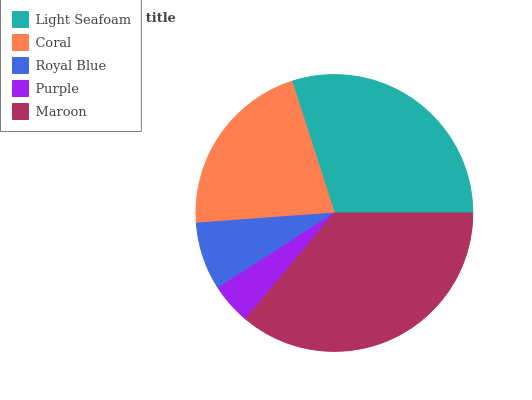Is Purple the minimum?
Answer yes or no. Yes. Is Maroon the maximum?
Answer yes or no. Yes. Is Coral the minimum?
Answer yes or no. No. Is Coral the maximum?
Answer yes or no. No. Is Light Seafoam greater than Coral?
Answer yes or no. Yes. Is Coral less than Light Seafoam?
Answer yes or no. Yes. Is Coral greater than Light Seafoam?
Answer yes or no. No. Is Light Seafoam less than Coral?
Answer yes or no. No. Is Coral the high median?
Answer yes or no. Yes. Is Coral the low median?
Answer yes or no. Yes. Is Maroon the high median?
Answer yes or no. No. Is Maroon the low median?
Answer yes or no. No. 